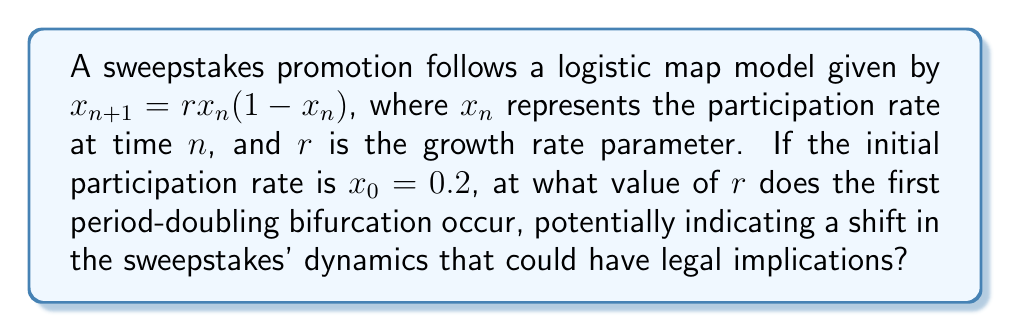Solve this math problem. To find the first period-doubling bifurcation point in the logistic map, we need to follow these steps:

1) The logistic map is given by $x_{n+1} = rx_n(1-x_n)$.

2) At the fixed point, $x_{n+1} = x_n = x^*$. So, we solve:
   $x^* = rx^*(1-x^*)$

3) Solving this equation gives two fixed points:
   $x^* = 0$ and $x^* = 1 - \frac{1}{r}$

4) The non-zero fixed point $x^* = 1 - \frac{1}{r}$ is stable when $|f'(x^*)| < 1$, where $f'(x) = r(1-2x)$.

5) Calculating $f'(x^*)$:
   $f'(1-\frac{1}{r}) = r(1-2(1-\frac{1}{r})) = r(1-2+\frac{2}{r}) = 2-r$

6) The stability condition $|f'(x^*)| < 1$ becomes:
   $|2-r| < 1$

7) Solving this inequality:
   $-1 < 2-r < 1$
   $1 < r < 3$

8) The first period-doubling bifurcation occurs when $f'(x^*) = -1$:
   $2-r = -1$
   $r = 3$

Therefore, the first period-doubling bifurcation occurs at $r = 3$. This is where the system transitions from a stable fixed point to a 2-cycle, potentially indicating a significant change in participation patterns that could have legal implications for the sweepstakes.
Answer: $r = 3$ 